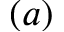Convert formula to latex. <formula><loc_0><loc_0><loc_500><loc_500>( a )</formula> 